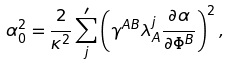<formula> <loc_0><loc_0><loc_500><loc_500>\alpha _ { 0 } ^ { 2 } = \frac { 2 } { \kappa ^ { 2 } } \sum _ { j } ^ { \prime } \left ( \gamma ^ { A B } \lambda ^ { j } _ { A } \frac { \partial \alpha } { \partial \Phi ^ { B } } \right ) ^ { 2 } ,</formula> 